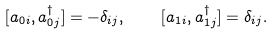<formula> <loc_0><loc_0><loc_500><loc_500>[ a _ { 0 i } , a ^ { \dagger } _ { 0 j } ] = - \delta _ { i j } , \quad [ a _ { 1 i } , a ^ { \dagger } _ { 1 j } ] = \delta _ { i j } .</formula> 